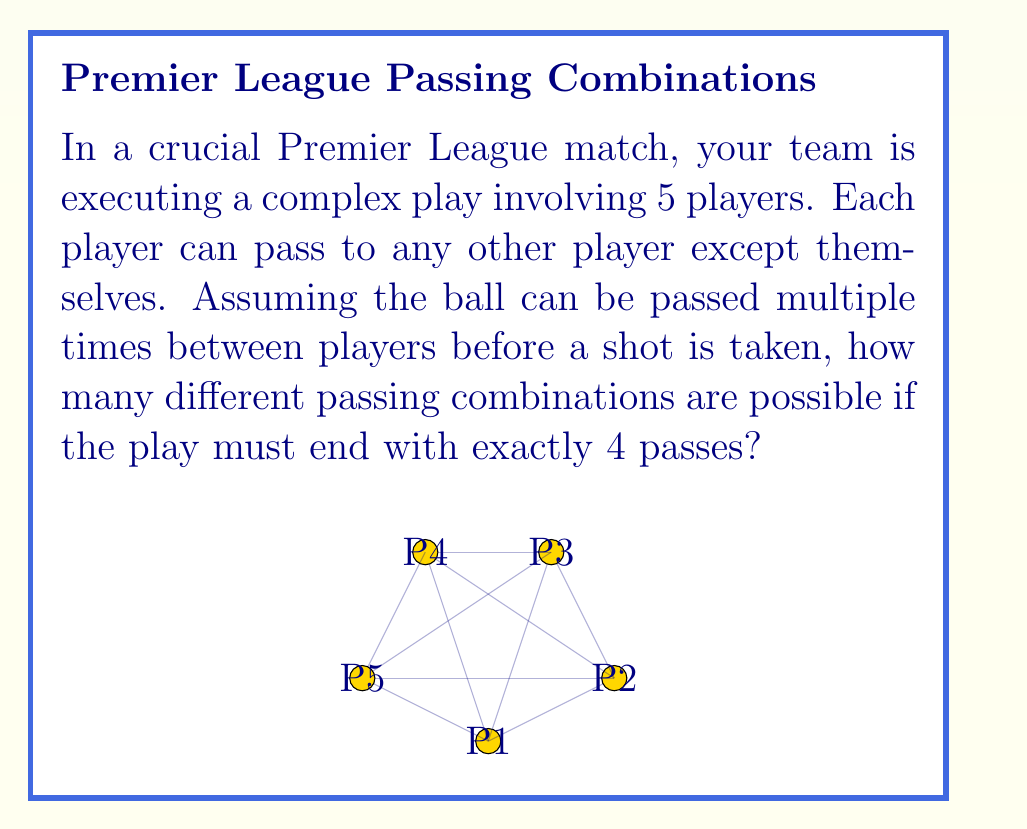Help me with this question. Let's approach this step-by-step:

1) First, we need to understand that for each pass, a player has 4 options (all other players except themselves).

2) We need to make exactly 4 passes, and each pass is independent of the others.

3) This scenario can be modeled using the multiplication principle of counting.

4) For the first pass, we have 5 choices of players who can start with the ball, and they have 4 options to pass to.

5) For each subsequent pass, the player with the ball always has 4 options.

6) Therefore, the total number of possible passing combinations is:

   $$5 \times 4 \times 4 \times 4 \times 4$$

7) This can be written as:

   $$5 \times 4^4$$

8) Calculating:
   $$5 \times 4^4 = 5 \times 256 = 1280$$

Thus, there are 1280 different possible passing combinations in this play.
Answer: 1280 